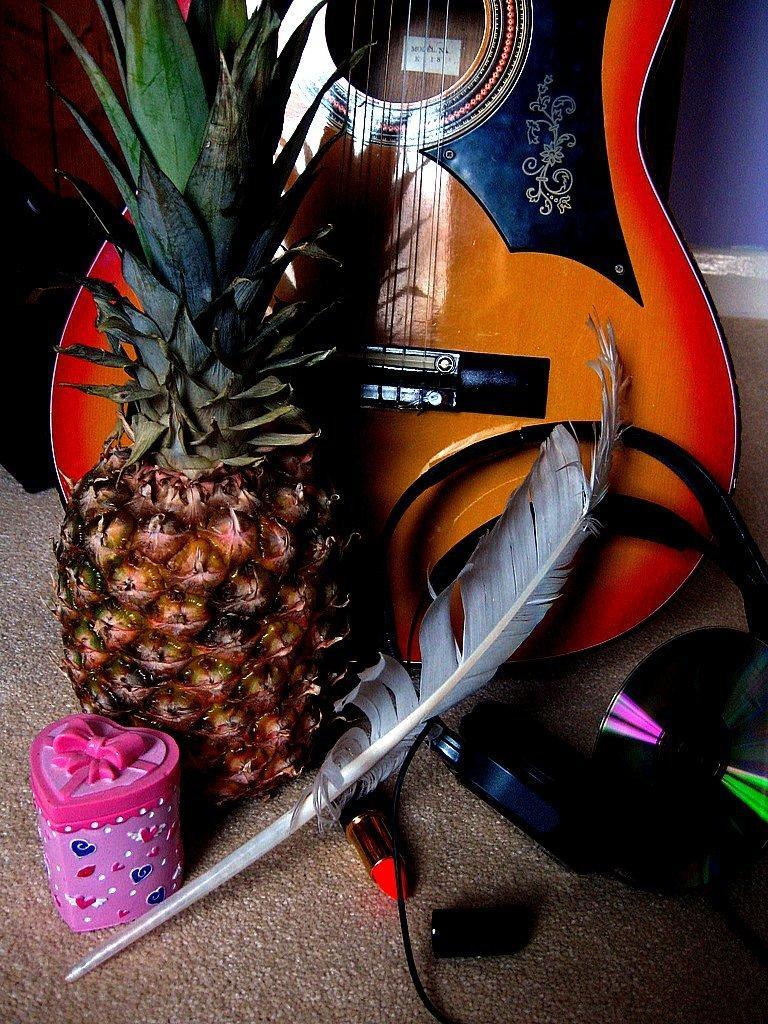In one or two sentences, can you explain what this image depicts? In the picture there is one gift box, feather, one cd and headset and a pineapple, behind them there is a guitar in wood colour. 